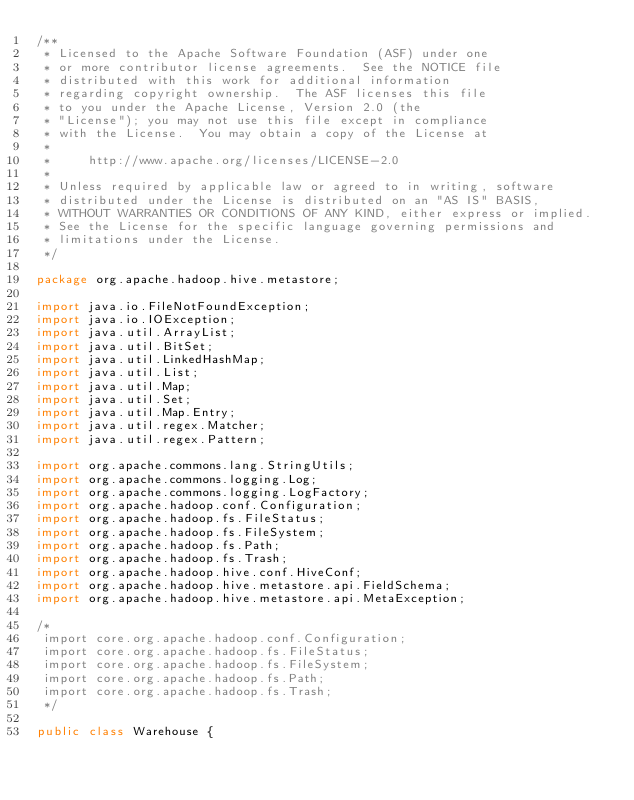<code> <loc_0><loc_0><loc_500><loc_500><_Java_>/**
 * Licensed to the Apache Software Foundation (ASF) under one
 * or more contributor license agreements.  See the NOTICE file
 * distributed with this work for additional information
 * regarding copyright ownership.  The ASF licenses this file
 * to you under the Apache License, Version 2.0 (the
 * "License"); you may not use this file except in compliance
 * with the License.  You may obtain a copy of the License at
 *
 *     http://www.apache.org/licenses/LICENSE-2.0
 * 
 * Unless required by applicable law or agreed to in writing, software
 * distributed under the License is distributed on an "AS IS" BASIS,
 * WITHOUT WARRANTIES OR CONDITIONS OF ANY KIND, either express or implied.
 * See the License for the specific language governing permissions and
 * limitations under the License.
 */

package org.apache.hadoop.hive.metastore;

import java.io.FileNotFoundException;
import java.io.IOException;
import java.util.ArrayList;
import java.util.BitSet;
import java.util.LinkedHashMap;
import java.util.List;
import java.util.Map;
import java.util.Set;
import java.util.Map.Entry;
import java.util.regex.Matcher;
import java.util.regex.Pattern;

import org.apache.commons.lang.StringUtils;
import org.apache.commons.logging.Log;
import org.apache.commons.logging.LogFactory;
import org.apache.hadoop.conf.Configuration;
import org.apache.hadoop.fs.FileStatus;
import org.apache.hadoop.fs.FileSystem;
import org.apache.hadoop.fs.Path;
import org.apache.hadoop.fs.Trash;
import org.apache.hadoop.hive.conf.HiveConf;
import org.apache.hadoop.hive.metastore.api.FieldSchema;
import org.apache.hadoop.hive.metastore.api.MetaException;

/*
 import core.org.apache.hadoop.conf.Configuration;
 import core.org.apache.hadoop.fs.FileStatus;
 import core.org.apache.hadoop.fs.FileSystem;
 import core.org.apache.hadoop.fs.Path;
 import core.org.apache.hadoop.fs.Trash;
 */

public class Warehouse {</code> 